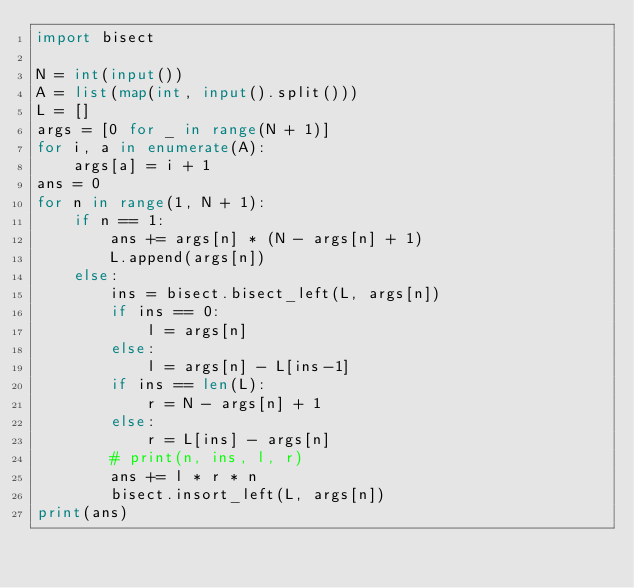<code> <loc_0><loc_0><loc_500><loc_500><_Python_>import bisect

N = int(input())
A = list(map(int, input().split()))
L = []
args = [0 for _ in range(N + 1)]
for i, a in enumerate(A):
    args[a] = i + 1
ans = 0
for n in range(1, N + 1):
    if n == 1:
        ans += args[n] * (N - args[n] + 1)
        L.append(args[n])
    else:
        ins = bisect.bisect_left(L, args[n])
        if ins == 0:
            l = args[n]
        else:
            l = args[n] - L[ins-1]
        if ins == len(L):
            r = N - args[n] + 1
        else:
            r = L[ins] - args[n]
        # print(n, ins, l, r)
        ans += l * r * n
        bisect.insort_left(L, args[n])
print(ans)
</code> 